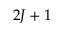<formula> <loc_0><loc_0><loc_500><loc_500>2 J + 1</formula> 